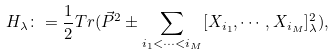Convert formula to latex. <formula><loc_0><loc_0><loc_500><loc_500>H _ { \lambda } \colon = \frac { 1 } { 2 } T r ( \vec { P } ^ { 2 } \pm \sum _ { i _ { 1 } < \cdots < i _ { M } } [ X _ { i _ { 1 } } , \cdots , X _ { i _ { M } } ] _ { \lambda } ^ { 2 } ) ,</formula> 